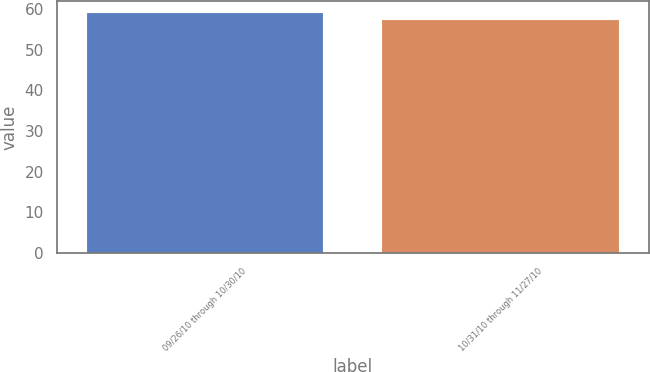<chart> <loc_0><loc_0><loc_500><loc_500><bar_chart><fcel>09/26/10 through 10/30/10<fcel>10/31/10 through 11/27/10<nl><fcel>59.02<fcel>57.3<nl></chart> 